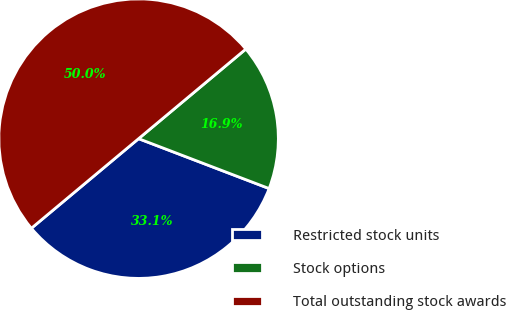<chart> <loc_0><loc_0><loc_500><loc_500><pie_chart><fcel>Restricted stock units<fcel>Stock options<fcel>Total outstanding stock awards<nl><fcel>33.11%<fcel>16.89%<fcel>50.0%<nl></chart> 